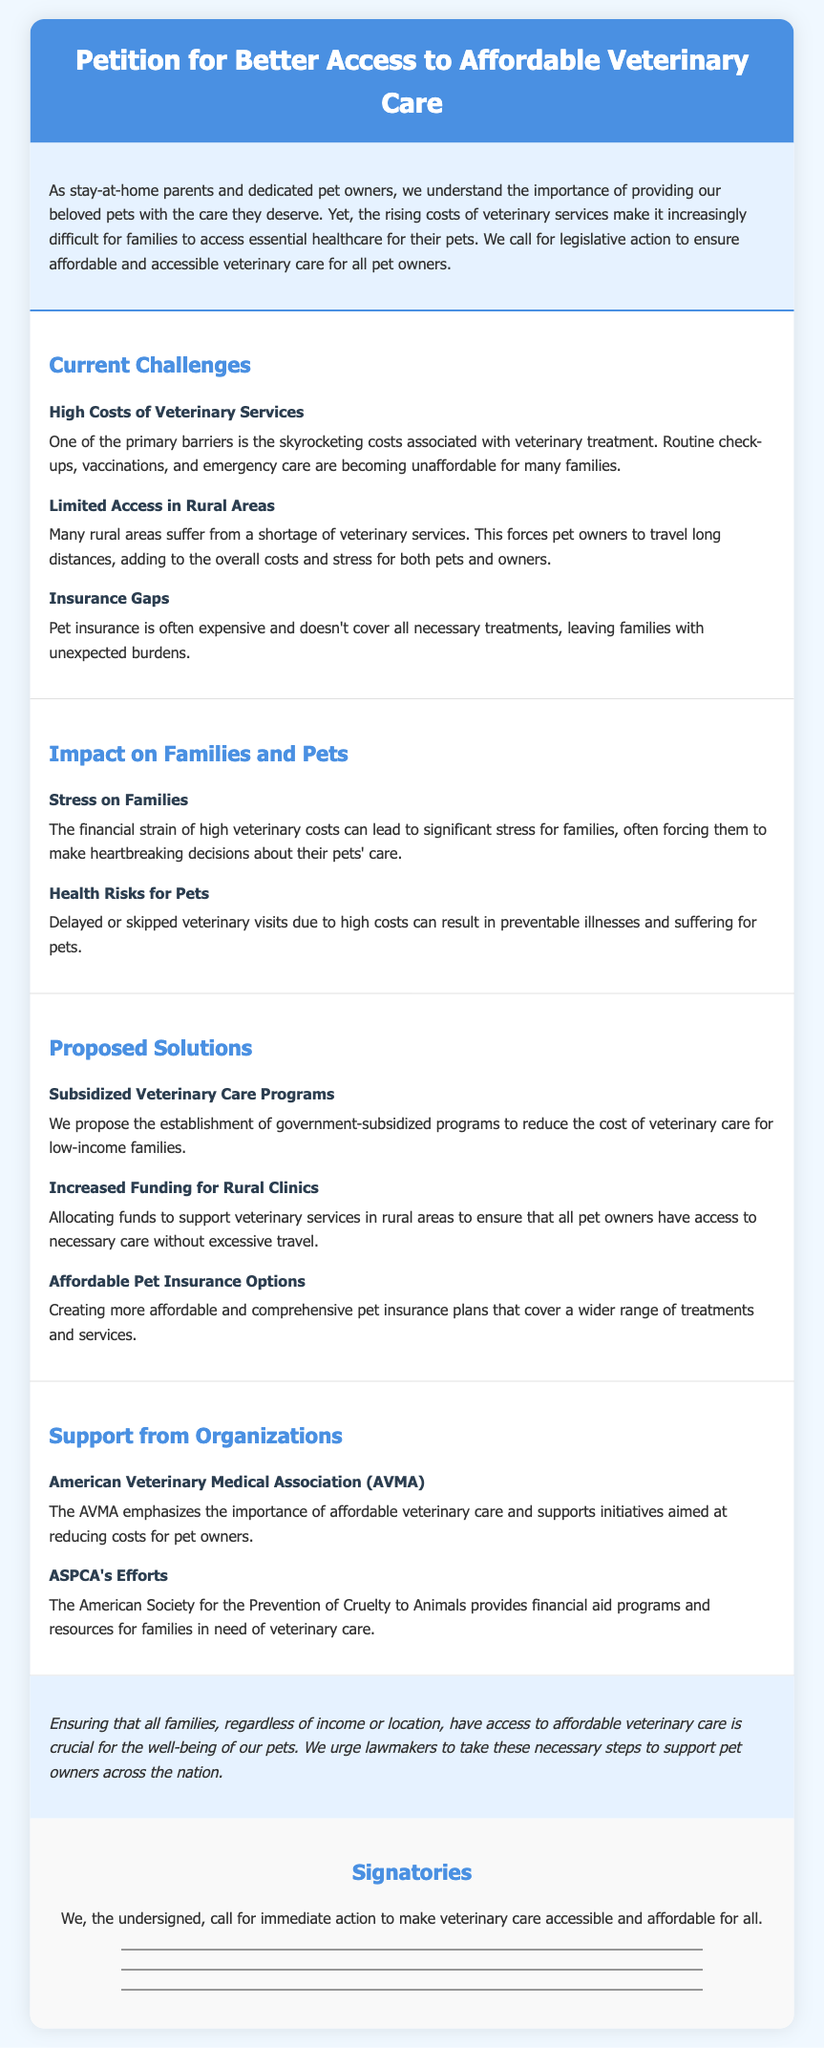What is the title of the petition? The title of the petition is explicitly stated at the top of the document, highlighting the main focus of the petition.
Answer: Petition for Better Access to Affordable Veterinary Care What is one primary barrier to veterinary care mentioned? One of the main challenges highlighted in the document under "Current Challenges" section refers to the costs associated with veterinary treatment.
Answer: High Costs of Veterinary Services What organization emphasizes the importance of affordable veterinary care? The document mentions organizations that support affordable veterinary care; one such organization is specifically named in the "Support from Organizations" section.
Answer: American Veterinary Medical Association (AVMA) What is a proposed solution to assist low-income families? The petition outlines specific solutions, and one is aimed at supporting families in need of financial assistance with veterinary care.
Answer: Subsidized Veterinary Care Programs What is a significant impact on families due to high veterinary costs? The document explains various impacts on families and one significant emotional consequence is discussed under the impact section.
Answer: Stress on Families Which area faces a shortage of veterinary services? The document specifies certain geographic areas that struggle to provide adequate veterinary services, particularly affecting pet owners' access to care.
Answer: Rural Areas What does the ASPCA provide for families in need? The document notes efforts from organizations to assist families, and one specific support provided by the ASPCA is mentioned.
Answer: Financial aid programs How does high veterinary care cost affect pets' health? The petition discusses the consequences of high costs on pet health, resulting in specific negative outcomes.
Answer: Health Risks for Pets 